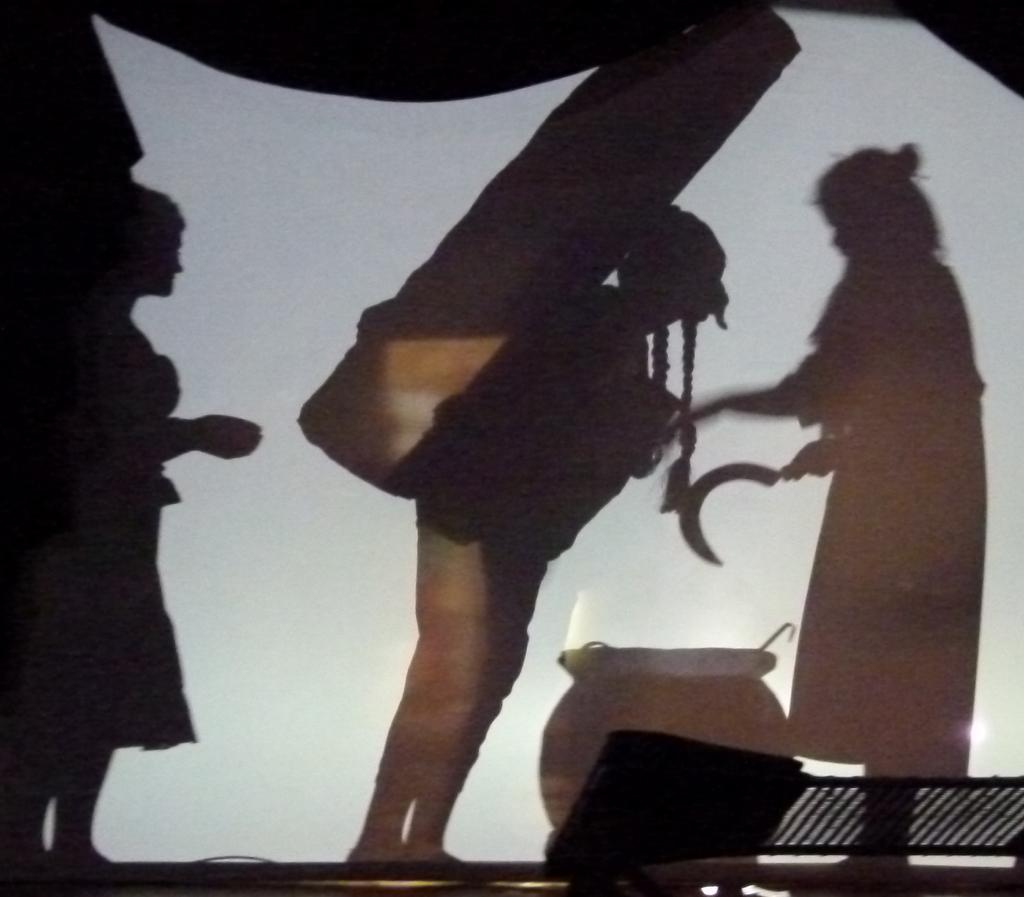How many shadows of people can be seen in the image? There are shadows of three persons in the image. What is one person doing in the image? One person is holding something in the image. What object is present at the bottom of the image? There is a pot at the bottom of the image. What type of mountain can be seen in the background of the image? There is no mountain present in the image. How many letters are visible on the pot at the bottom of the image? There are no letters visible on the pot at the bottom of the image. 